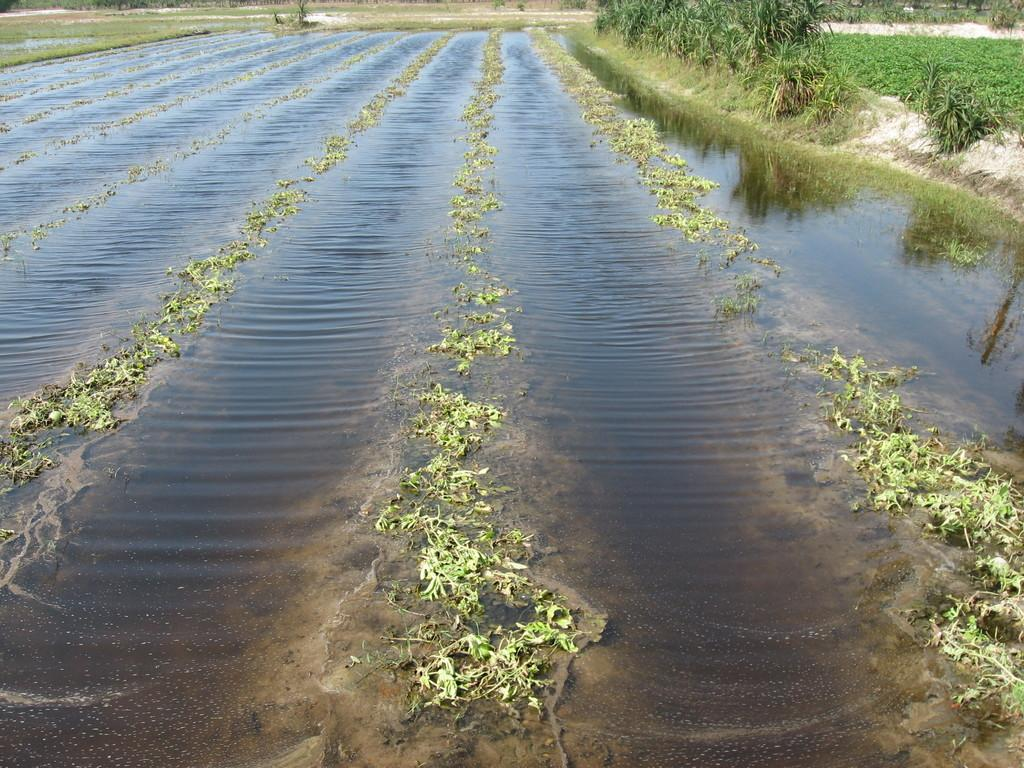What type of landscape is depicted in the image? There is a field with water in the image. What can be seen in the background of the image? There are plants visible in the background of the image. What type of respect can be seen in the image? There is no indication of respect in the image, as it features a field with water and plants in the background. What is the ice used for in the image? There is no ice present in the image. What is the hammer used for in the image? There is no hammer present in the image. 